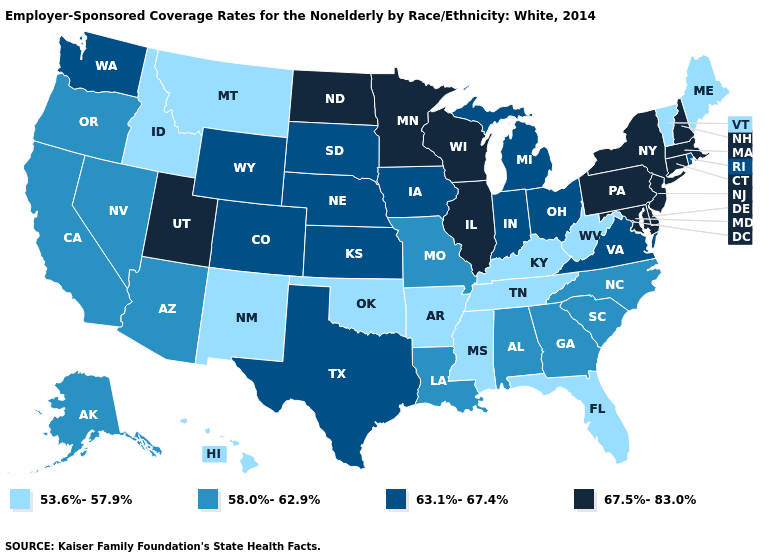Does North Carolina have the same value as Indiana?
Quick response, please. No. What is the value of Delaware?
Short answer required. 67.5%-83.0%. Name the states that have a value in the range 63.1%-67.4%?
Keep it brief. Colorado, Indiana, Iowa, Kansas, Michigan, Nebraska, Ohio, Rhode Island, South Dakota, Texas, Virginia, Washington, Wyoming. What is the value of South Dakota?
Keep it brief. 63.1%-67.4%. Does the map have missing data?
Keep it brief. No. Does Maryland have the lowest value in the South?
Short answer required. No. Does Idaho have the lowest value in the USA?
Quick response, please. Yes. Does Utah have a higher value than Illinois?
Be succinct. No. Name the states that have a value in the range 58.0%-62.9%?
Keep it brief. Alabama, Alaska, Arizona, California, Georgia, Louisiana, Missouri, Nevada, North Carolina, Oregon, South Carolina. Does the map have missing data?
Write a very short answer. No. Does Maryland have the highest value in the South?
Short answer required. Yes. Which states have the highest value in the USA?
Answer briefly. Connecticut, Delaware, Illinois, Maryland, Massachusetts, Minnesota, New Hampshire, New Jersey, New York, North Dakota, Pennsylvania, Utah, Wisconsin. Which states have the lowest value in the South?
Short answer required. Arkansas, Florida, Kentucky, Mississippi, Oklahoma, Tennessee, West Virginia. What is the highest value in the USA?
Give a very brief answer. 67.5%-83.0%. Name the states that have a value in the range 53.6%-57.9%?
Be succinct. Arkansas, Florida, Hawaii, Idaho, Kentucky, Maine, Mississippi, Montana, New Mexico, Oklahoma, Tennessee, Vermont, West Virginia. 